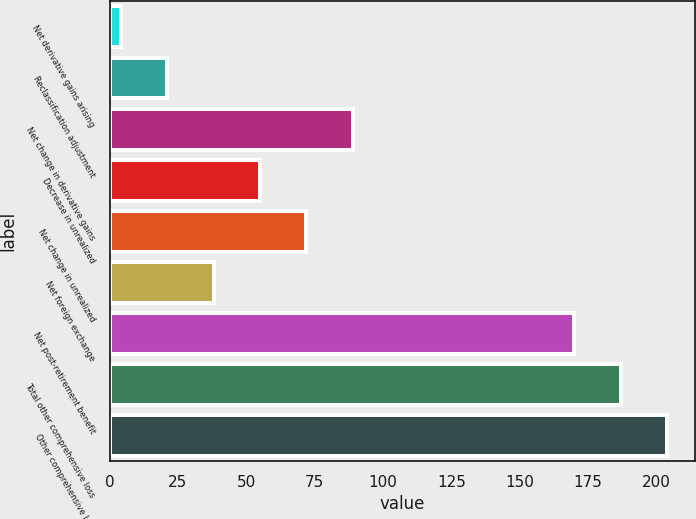Convert chart to OTSL. <chart><loc_0><loc_0><loc_500><loc_500><bar_chart><fcel>Net derivative gains arising<fcel>Reclassification adjustment<fcel>Net change in derivative gains<fcel>Decrease in unrealized<fcel>Net change in unrealized<fcel>Net foreign exchange<fcel>Net post-retirement benefit<fcel>Total other comprehensive loss<fcel>Other comprehensive loss<nl><fcel>4<fcel>21<fcel>89<fcel>55<fcel>72<fcel>38<fcel>170<fcel>187<fcel>204<nl></chart> 